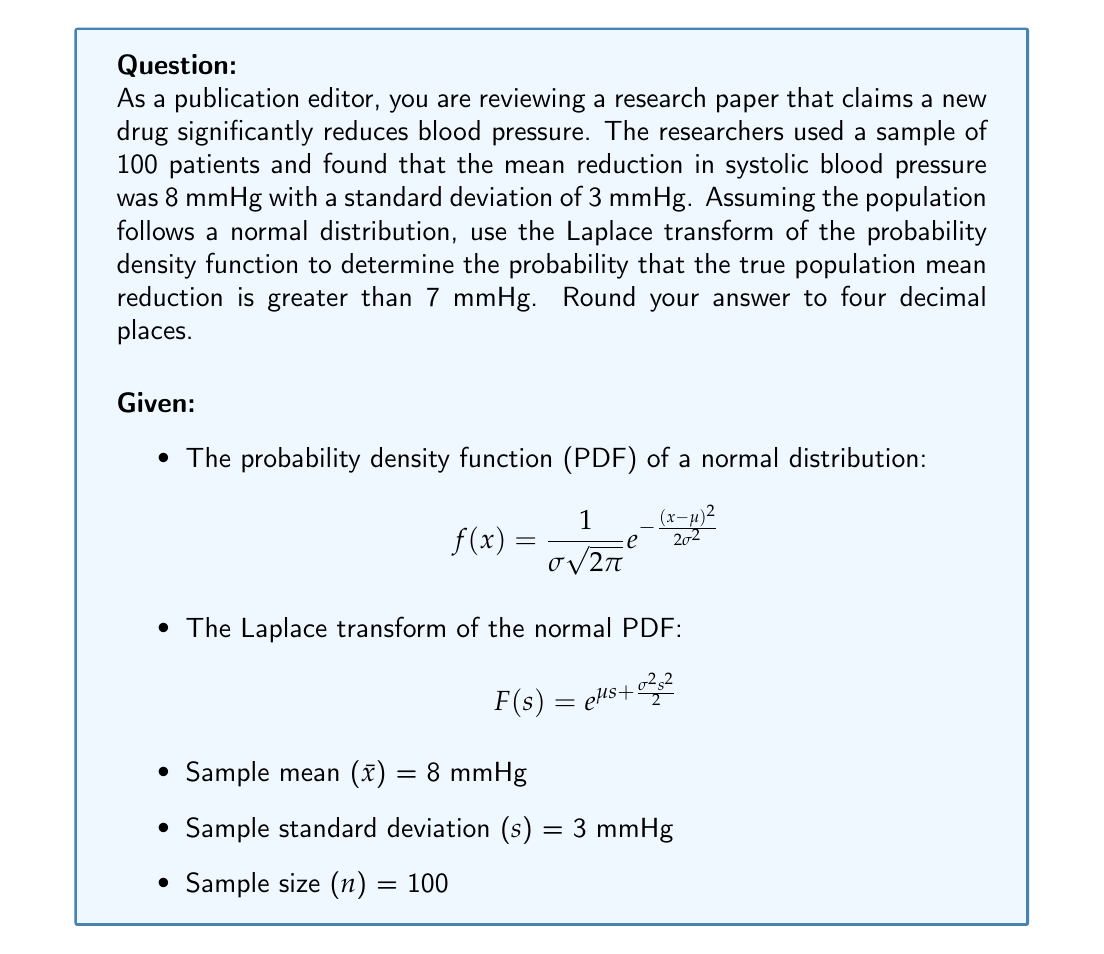Help me with this question. 1) First, we need to calculate the standard error of the mean:
   $$SE = \frac{s}{\sqrt{n}} = \frac{3}{\sqrt{100}} = 0.3$$

2) The distribution of the sample mean follows a normal distribution with:
   $$\mu = 8$$ (sample mean)
   $$\sigma = 0.3$$ (standard error)

3) We want to find $P(\mu > 7)$, which is equivalent to $P(Z > \frac{7-8}{0.3})$, where Z is the standard normal variable.

4) Calculate the Z-score:
   $$Z = \frac{7-8}{0.3} = -3.33$$

5) Now, we need to find $P(Z > -3.33)$. Instead of using standard normal tables, we'll use the Laplace transform method.

6) The Laplace transform of the standard normal PDF is:
   $$F(s) = e^{\frac{s^2}{2}}$$

7) To find the probability, we use the following property:
   $$P(Z > a) = \frac{1}{2\pi i} \int_{c-i\infty}^{c+i\infty} \frac{e^{\frac{s^2}{2}}}{s} e^{-as} ds$$

8) This integral can be evaluated using contour integration, but the result is equivalent to:
   $$P(Z > a) = \frac{1}{2} - \frac{1}{2}\text{erf}(\frac{a}{\sqrt{2}})$$

   where erf is the error function.

9) Substituting our value:
   $$P(Z > -3.33) = \frac{1}{2} - \frac{1}{2}\text{erf}(\frac{-3.33}{\sqrt{2}})$$

10) Using a calculator or computational tool to evaluate this:
    $$P(Z > -3.33) \approx 0.9996$$
Answer: 0.9996 